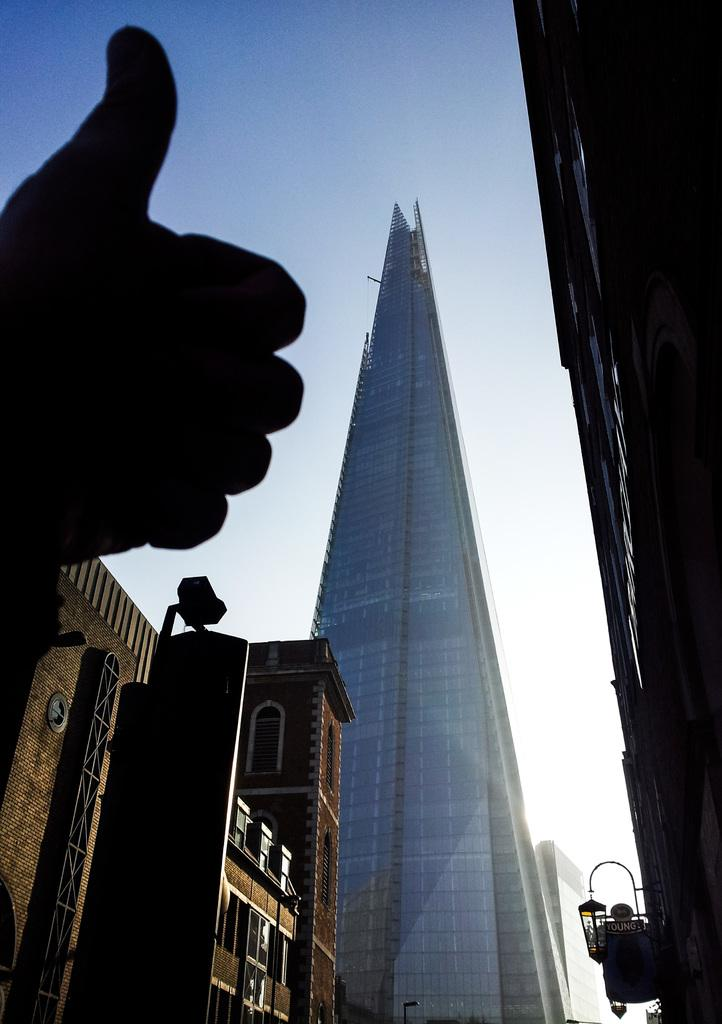What is located on the left side of the image? There is a hand of a human on the left side of the image. What can be seen in the middle of the image? There are big buildings in the middle of the image. What is visible at the top of the image? The sky is visible at the top of the image. What type of wealth is depicted in the image? There is no depiction of wealth in the image; it features a hand and big buildings. What religion is practiced in the town shown in the image? There is no town or indication of religion in the image; it only shows a hand, big buildings, and the sky. 